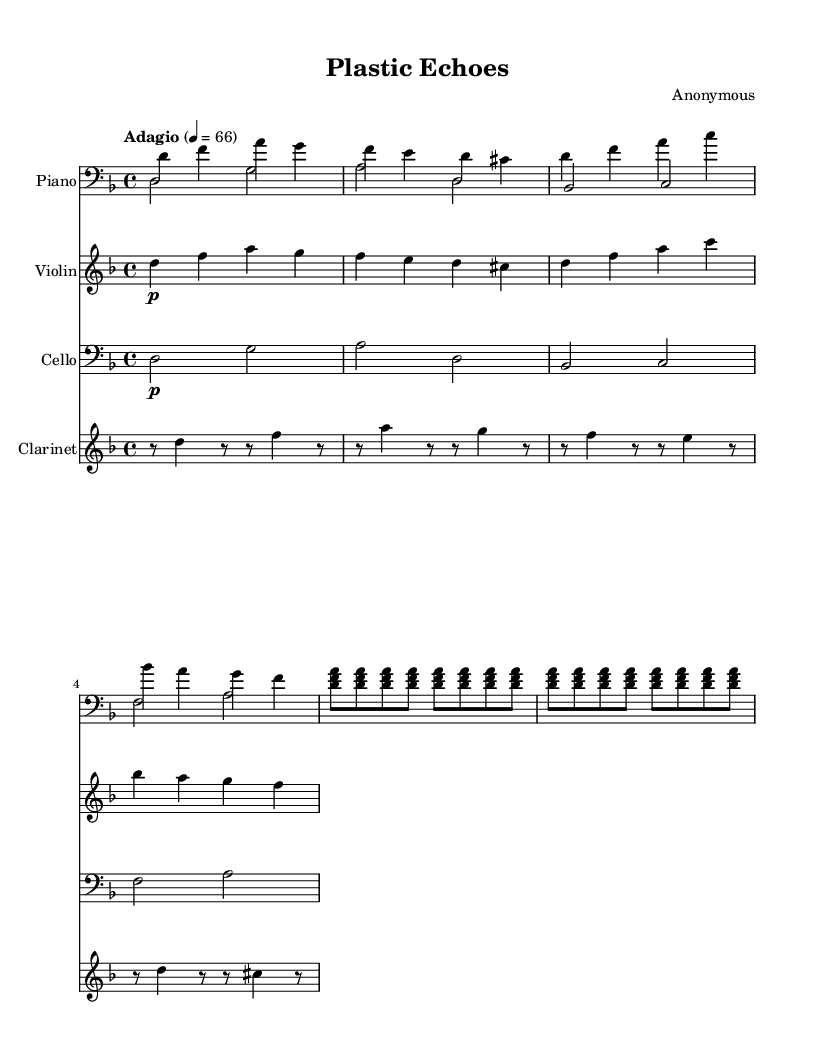What is the key signature of this music? The key signature is D minor, which has one flat (B flat). This can be determined by looking at the key signature indicated at the beginning of the staff.
Answer: D minor What is the time signature of this music? The time signature is 4/4, which means there are four beats in a measure and the quarter note gets one beat. This is indicated at the beginning of the piece, right after the key signature.
Answer: 4/4 What is the tempo marking of this piece? The tempo marking is "Adagio," which indicates a slow pace. This can be found at the top of the piece, indicating how fast the music should be played.
Answer: Adagio How many times is the phrase in measures 5-12 repeated? The phrase in measures 5-12, which consists of a repeated four-note chord pattern, is repeated two times as noted by the "repeat" symbol.
Answer: 2 What instruments are featured in this composition? The instruments featured in this composition are Piano, Violin, Cello, and Clarinet, as shown by the instrument names at the beginning of each staff.
Answer: Piano, Violin, Cello, Clarinet What dynamic marking is used for the clarinet in the first section? The clarinet has a dynamic marking of "p" indicating it should be played piano (soft). This is noted directly under the first note of the clarinet staff.
Answer: p What is the relationship between the piano and violin parts in the context of this piece? The piano and violin parts are harmonically intertwined, as the violin plays a melodic line that is complemented by the piano's accompaniment with chords and bass notes. This is understood through analyzing the interactions of the notes played by both instruments throughout the piece.
Answer: Harmonically intertwined 